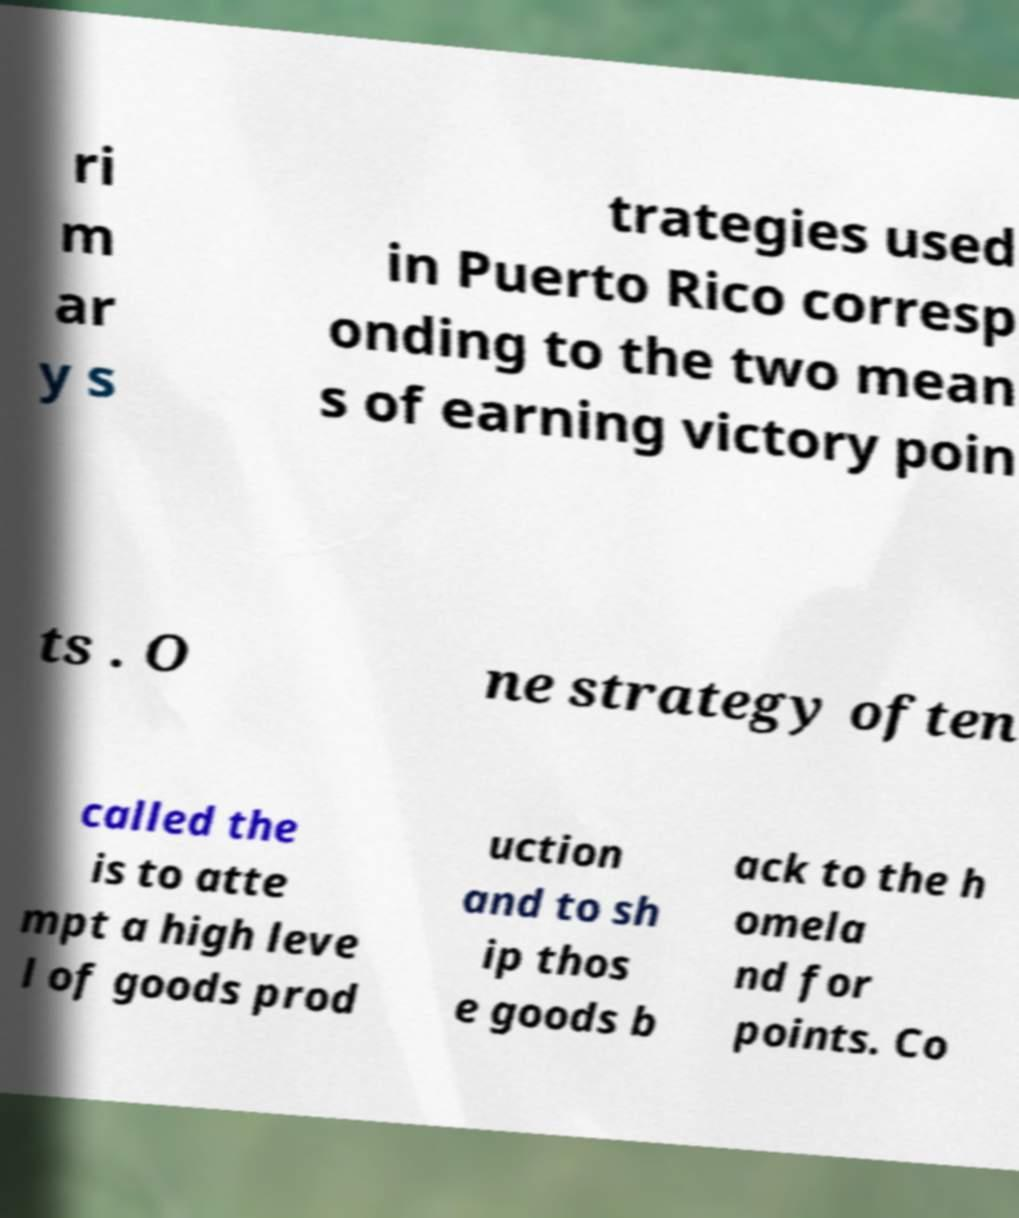Please identify and transcribe the text found in this image. ri m ar y s trategies used in Puerto Rico corresp onding to the two mean s of earning victory poin ts . O ne strategy often called the is to atte mpt a high leve l of goods prod uction and to sh ip thos e goods b ack to the h omela nd for points. Co 